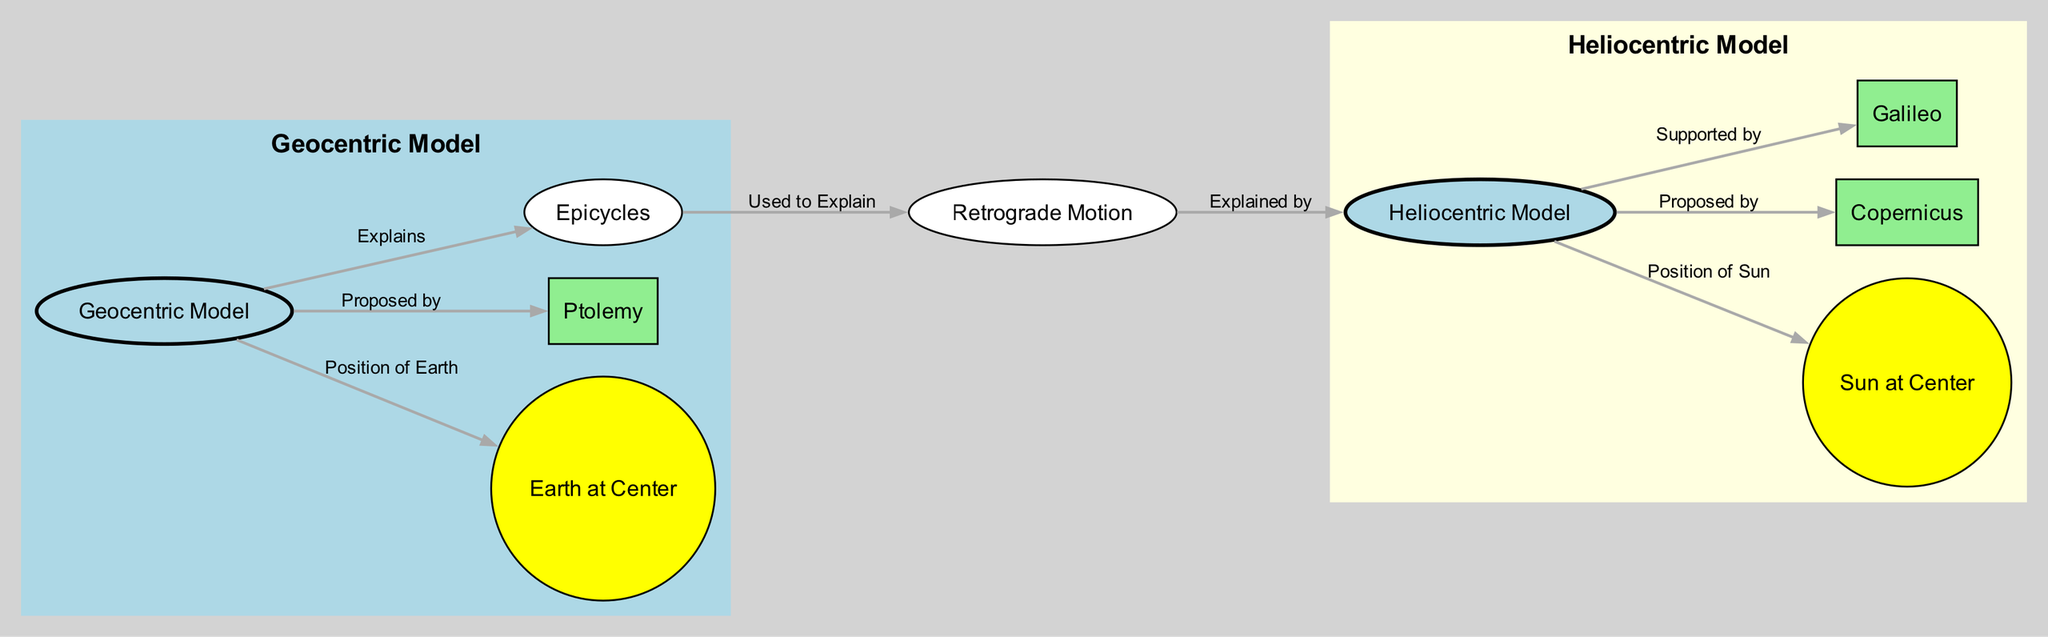What are the two main models depicted in the diagram? The diagram clearly shows the "Geocentric Model" and the "Heliocentric Model" as the two main models of the universe.
Answer: Geocentric Model, Heliocentric Model Who proposed the Geocentric Model? The diagram indicates that the Geocentric Model was proposed by "Ptolemy," which is directly stated in the connection from the Geocentric node.
Answer: Ptolemy Which motion is explained by the use of epicycles in the Geocentric Model? According to the diagram, epicycles are used to explain "Retrograde Motion," illustrating how this phenomenon was tackled by the proponents of the Geocentric Model.
Answer: Retrograde Motion What is the labeled position of the Sun in the Heliocentric Model? The diagram clearly marks "Sun at Center" as the position of the Sun in the Heliocentric Model, showing its central role in this theory.
Answer: Sun at Center Who supported the Heliocentric Model according to the diagram? The diagram connects the Heliocentric Model to "Galileo," indicating his support for this model, which was pivotal in its acceptance.
Answer: Galileo How many nodes are connected to the Geocentric Model? By examining the diagram, we can count the connections: "Earth at Center," "Ptolemy," "Epicycles," and one from "Epicycles" to "Retrograde Motion," resulting in four direct connections.
Answer: 4 What does "Retrograde Motion" explain according to its position in the diagram? The diagram shows that "Retrograde Motion" is explained by the Heliocentric Model, indicating a shift in understanding of planetary movements away from the Geocentric perspective.
Answer: Heliocentric Which model uses epicycles to explain planetary motion? From the diagram, it is evident that the Geocentric Model employs "Epicycles" for explaining planetary motion, particularly regarding retrograde motion.
Answer: Geocentric Model What is the primary function of the edges in this diagram? The edges serve to illustrate the relationships and connections between various concepts and figures, such as the proposals of models, the positions of celestial bodies, and explanations for observations.
Answer: Relationships and connections 